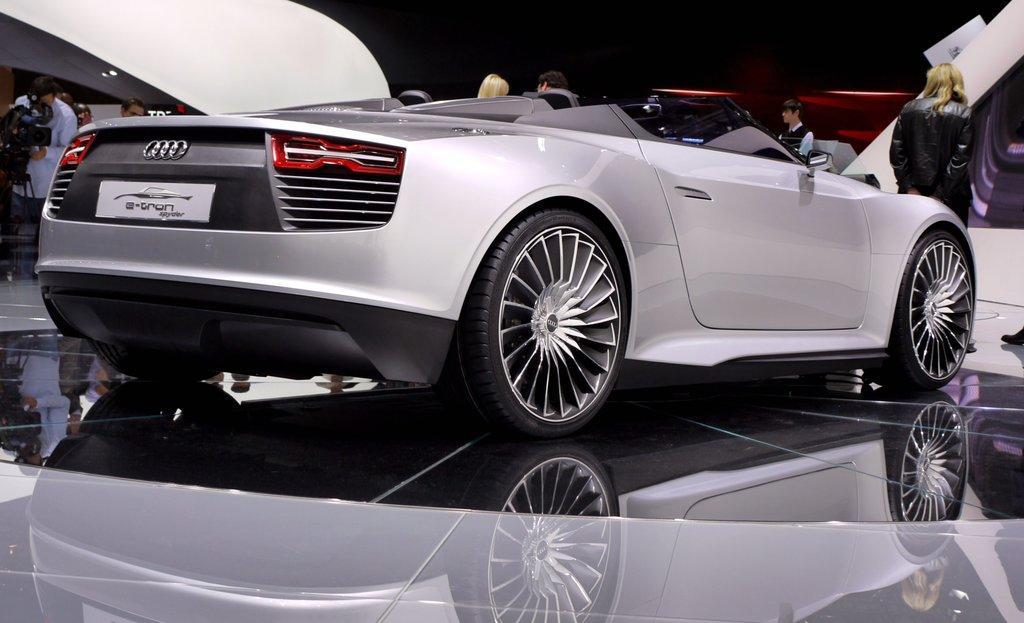How would you summarize this image in a sentence or two? In the center of the image we can see a car. On the left side of the image we can see a man is standing and holding a camera with stand. In the background of the image we can see the wall, lights and some people are standing. At the bottom of the image we can see the floor. 